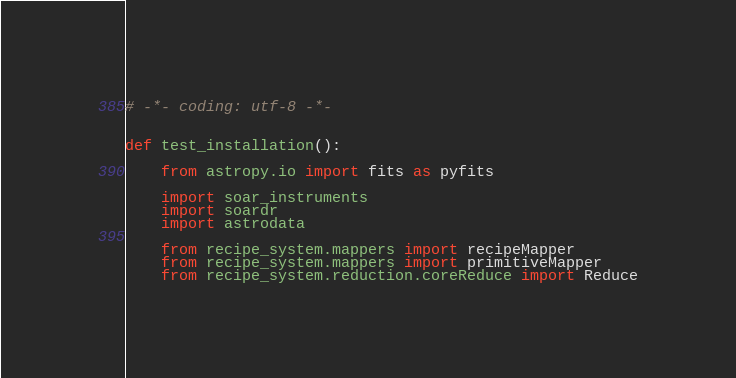Convert code to text. <code><loc_0><loc_0><loc_500><loc_500><_Python_># -*- coding: utf-8 -*-


def test_installation():

    from astropy.io import fits as pyfits

    import soar_instruments
    import soardr
    import astrodata

    from recipe_system.mappers import recipeMapper
    from recipe_system.mappers import primitiveMapper
    from recipe_system.reduction.coreReduce import Reduce</code> 